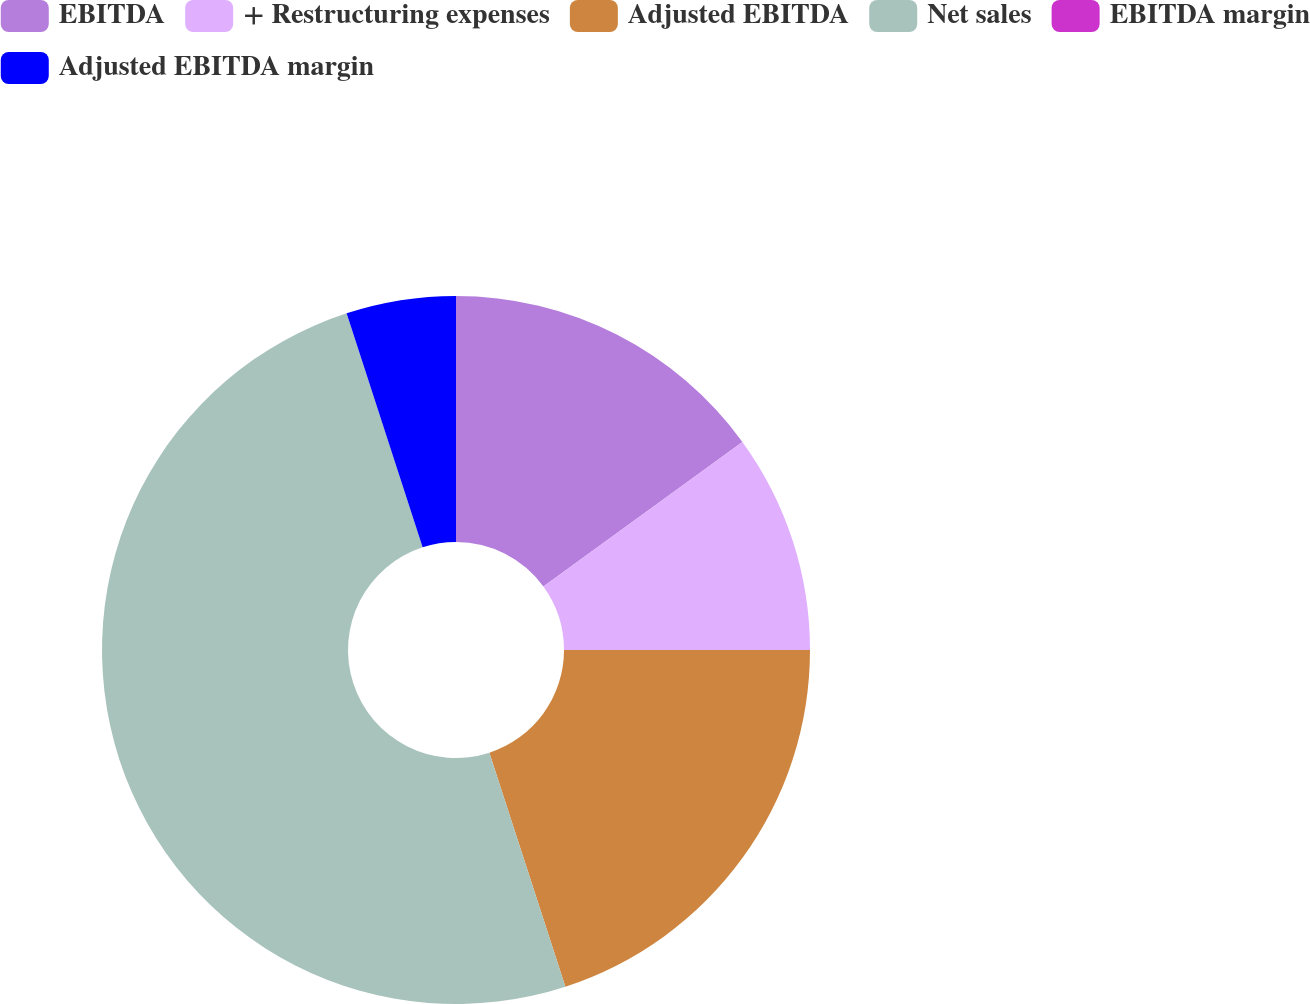Convert chart. <chart><loc_0><loc_0><loc_500><loc_500><pie_chart><fcel>EBITDA<fcel>+ Restructuring expenses<fcel>Adjusted EBITDA<fcel>Net sales<fcel>EBITDA margin<fcel>Adjusted EBITDA margin<nl><fcel>15.0%<fcel>10.0%<fcel>20.0%<fcel>50.0%<fcel>0.0%<fcel>5.0%<nl></chart> 